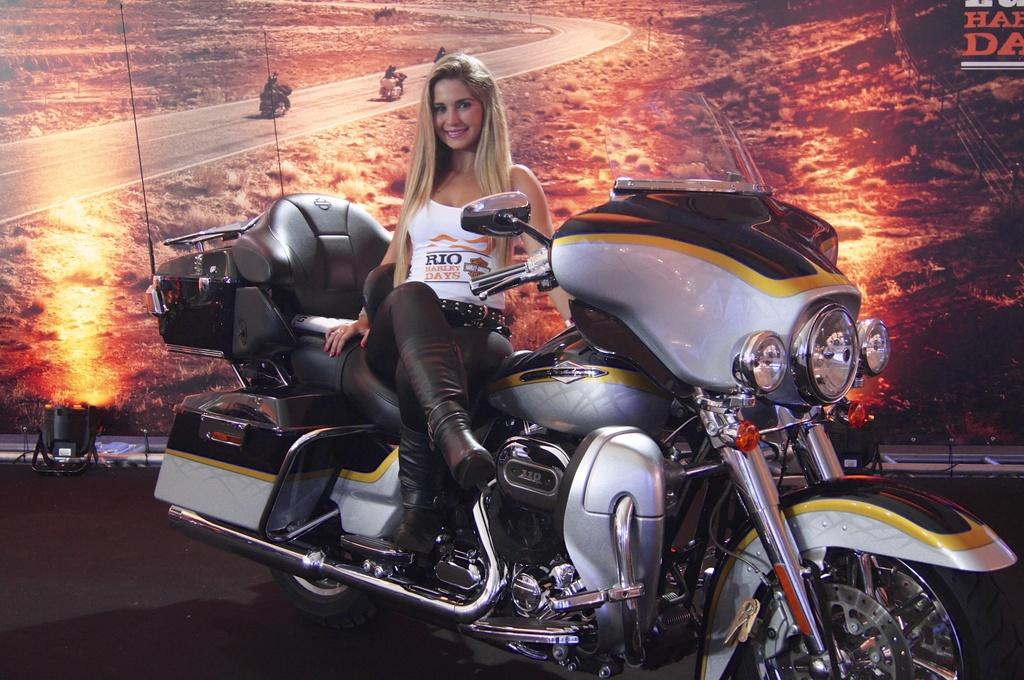What is the woman doing in the image? She is sitting on a motorcycle. What is her facial expression? She is smiling. What type of clothing accessory is she wearing? She is wearing a belt. What is she holding in the image? She is holding a motorcycle. What can be seen in the background of the image? There is a way visible in the background. What type of needle is she using to sew on the motorcycle? There is no needle present in the image, and she is not sewing on the motorcycle. How does the friction between the motorcycle and the road affect her ride? The image does not show her riding the motorcycle, so we cannot determine the effect of friction on her ride. 